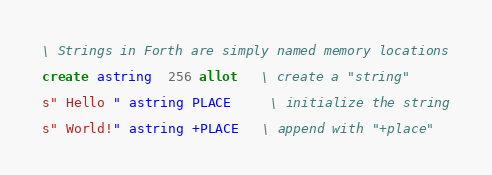Convert code to text. <code><loc_0><loc_0><loc_500><loc_500><_Forth_>\ Strings in Forth are simply named memory locations

create astring  256 allot   \ create a "string"

s" Hello " astring PLACE     \ initialize the string

s" World!" astring +PLACE   \ append with "+place"
</code> 